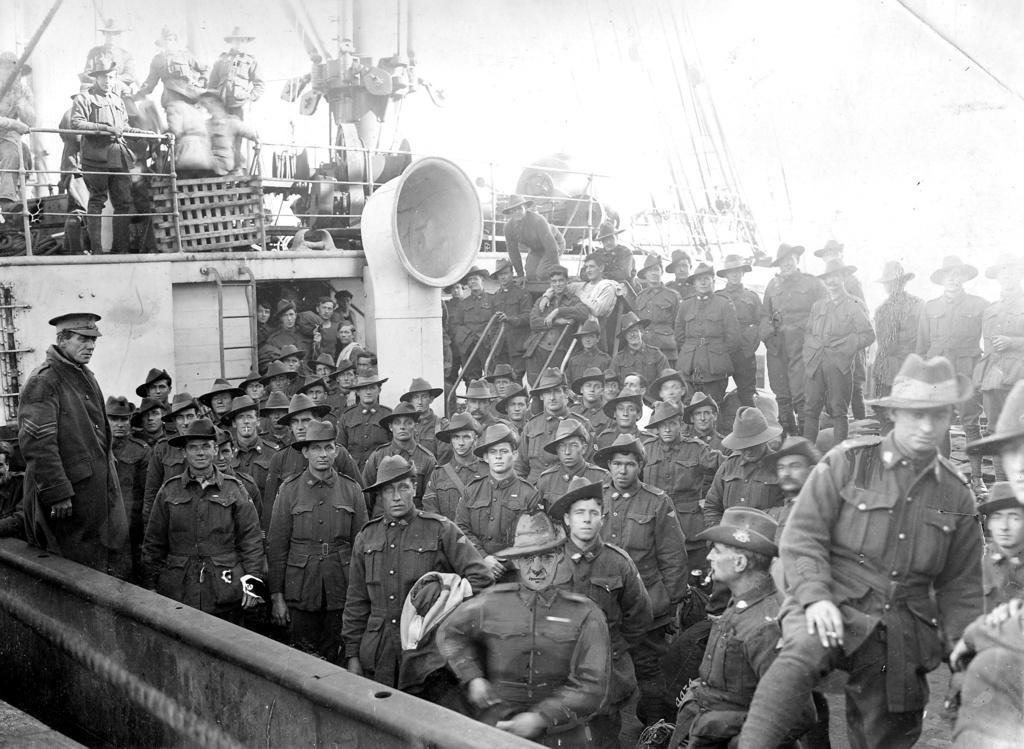Could you give a brief overview of what you see in this image? This is a black and white picture, in this image we can see a group of people, also we can see the wall, grille and some other objects. 